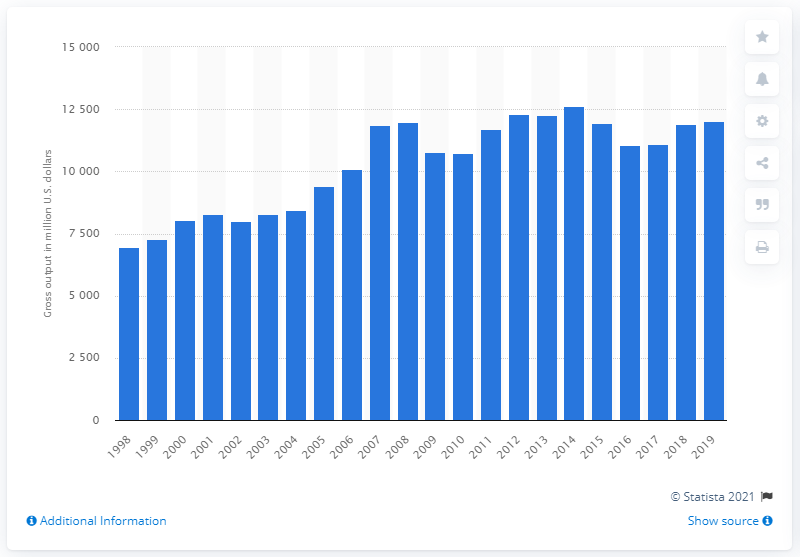Highlight a few significant elements in this photo. In 2019, the production of plastic bottles in the United States reached approximately 120,100 metric tons. 